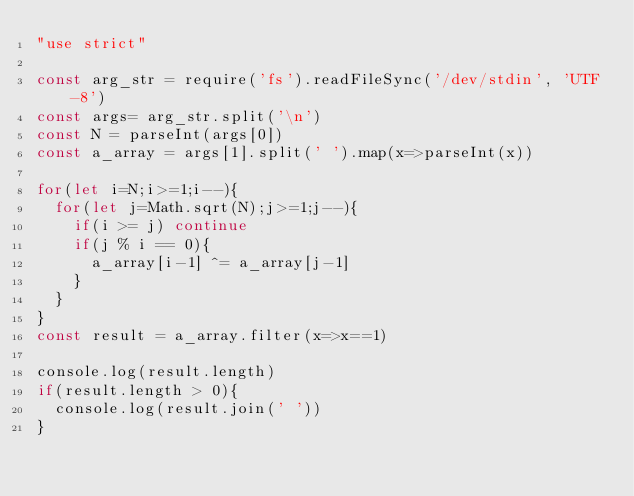<code> <loc_0><loc_0><loc_500><loc_500><_JavaScript_>"use strict"

const arg_str = require('fs').readFileSync('/dev/stdin', 'UTF-8')
const args= arg_str.split('\n')
const N = parseInt(args[0])
const a_array = args[1].split(' ').map(x=>parseInt(x))

for(let i=N;i>=1;i--){
  for(let j=Math.sqrt(N);j>=1;j--){
    if(i >= j) continue
    if(j % i == 0){
      a_array[i-1] ^= a_array[j-1]
    }
  }
}
const result = a_array.filter(x=>x==1)

console.log(result.length)
if(result.length > 0){
  console.log(result.join(' '))
}
</code> 